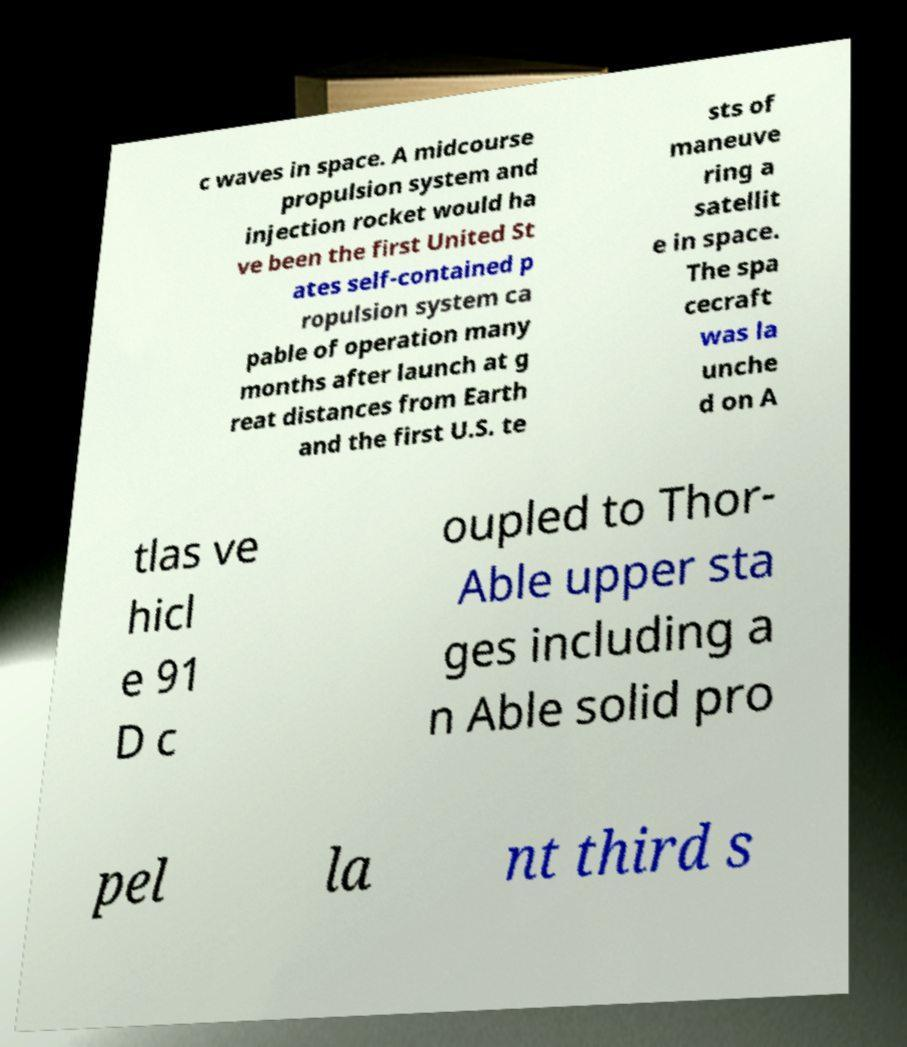Please identify and transcribe the text found in this image. c waves in space. A midcourse propulsion system and injection rocket would ha ve been the first United St ates self-contained p ropulsion system ca pable of operation many months after launch at g reat distances from Earth and the first U.S. te sts of maneuve ring a satellit e in space. The spa cecraft was la unche d on A tlas ve hicl e 91 D c oupled to Thor- Able upper sta ges including a n Able solid pro pel la nt third s 